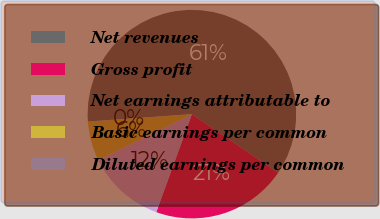<chart> <loc_0><loc_0><loc_500><loc_500><pie_chart><fcel>Net revenues<fcel>Gross profit<fcel>Net earnings attributable to<fcel>Basic earnings per common<fcel>Diluted earnings per common<nl><fcel>60.63%<fcel>21.05%<fcel>12.17%<fcel>6.11%<fcel>0.05%<nl></chart> 